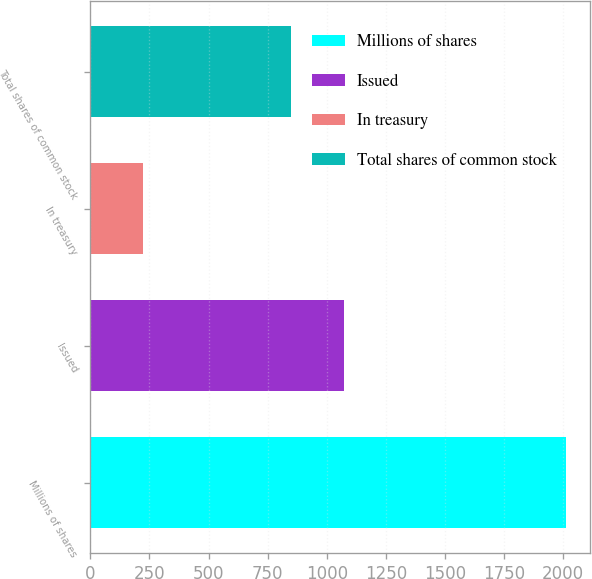Convert chart. <chart><loc_0><loc_0><loc_500><loc_500><bar_chart><fcel>Millions of shares<fcel>Issued<fcel>In treasury<fcel>Total shares of common stock<nl><fcel>2013<fcel>1072<fcel>223<fcel>849<nl></chart> 